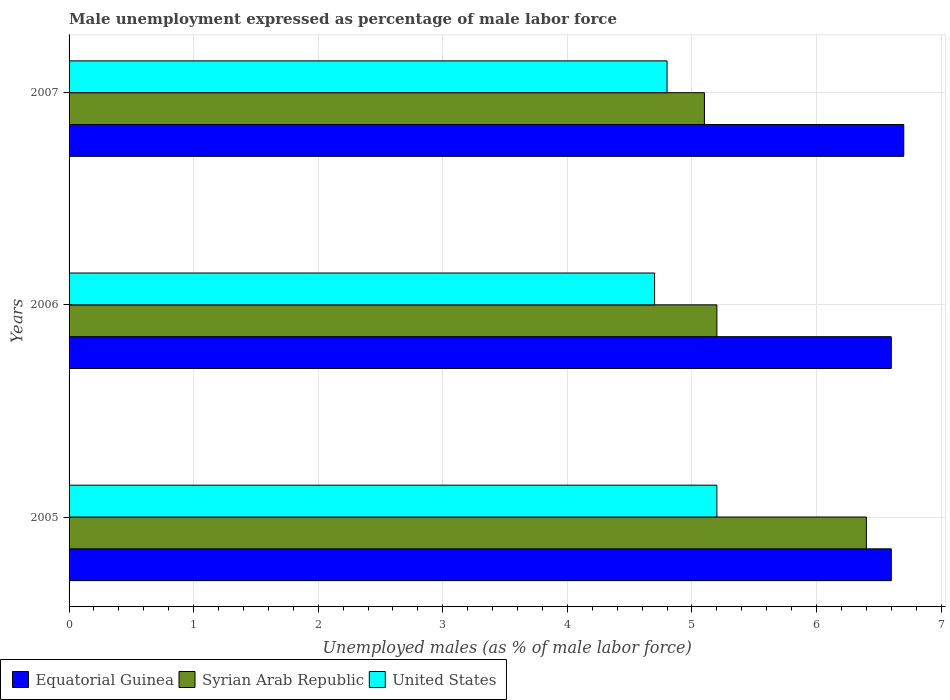How many different coloured bars are there?
Ensure brevity in your answer.  3. Are the number of bars per tick equal to the number of legend labels?
Provide a short and direct response. Yes. How many bars are there on the 2nd tick from the bottom?
Offer a very short reply. 3. In how many cases, is the number of bars for a given year not equal to the number of legend labels?
Make the answer very short. 0. What is the unemployment in males in in Equatorial Guinea in 2005?
Provide a short and direct response. 6.6. Across all years, what is the maximum unemployment in males in in Equatorial Guinea?
Make the answer very short. 6.7. Across all years, what is the minimum unemployment in males in in Equatorial Guinea?
Provide a short and direct response. 6.6. What is the total unemployment in males in in United States in the graph?
Make the answer very short. 14.7. What is the difference between the unemployment in males in in Equatorial Guinea in 2006 and that in 2007?
Make the answer very short. -0.1. What is the difference between the unemployment in males in in Equatorial Guinea in 2005 and the unemployment in males in in Syrian Arab Republic in 2007?
Offer a very short reply. 1.5. What is the average unemployment in males in in Equatorial Guinea per year?
Offer a very short reply. 6.63. In the year 2005, what is the difference between the unemployment in males in in United States and unemployment in males in in Equatorial Guinea?
Provide a short and direct response. -1.4. What is the ratio of the unemployment in males in in Equatorial Guinea in 2005 to that in 2007?
Provide a succinct answer. 0.99. What is the difference between the highest and the second highest unemployment in males in in United States?
Provide a short and direct response. 0.4. What is the difference between the highest and the lowest unemployment in males in in Equatorial Guinea?
Your response must be concise. 0.1. Is the sum of the unemployment in males in in Syrian Arab Republic in 2005 and 2007 greater than the maximum unemployment in males in in Equatorial Guinea across all years?
Provide a short and direct response. Yes. What does the 1st bar from the top in 2007 represents?
Offer a very short reply. United States. What does the 2nd bar from the bottom in 2006 represents?
Provide a succinct answer. Syrian Arab Republic. Is it the case that in every year, the sum of the unemployment in males in in Syrian Arab Republic and unemployment in males in in Equatorial Guinea is greater than the unemployment in males in in United States?
Provide a succinct answer. Yes. How many bars are there?
Offer a terse response. 9. How many years are there in the graph?
Keep it short and to the point. 3. Are the values on the major ticks of X-axis written in scientific E-notation?
Provide a short and direct response. No. Where does the legend appear in the graph?
Your answer should be very brief. Bottom left. How many legend labels are there?
Offer a terse response. 3. What is the title of the graph?
Ensure brevity in your answer.  Male unemployment expressed as percentage of male labor force. What is the label or title of the X-axis?
Keep it short and to the point. Unemployed males (as % of male labor force). What is the label or title of the Y-axis?
Ensure brevity in your answer.  Years. What is the Unemployed males (as % of male labor force) in Equatorial Guinea in 2005?
Provide a short and direct response. 6.6. What is the Unemployed males (as % of male labor force) in Syrian Arab Republic in 2005?
Give a very brief answer. 6.4. What is the Unemployed males (as % of male labor force) of United States in 2005?
Make the answer very short. 5.2. What is the Unemployed males (as % of male labor force) of Equatorial Guinea in 2006?
Give a very brief answer. 6.6. What is the Unemployed males (as % of male labor force) of Syrian Arab Republic in 2006?
Ensure brevity in your answer.  5.2. What is the Unemployed males (as % of male labor force) of United States in 2006?
Ensure brevity in your answer.  4.7. What is the Unemployed males (as % of male labor force) of Equatorial Guinea in 2007?
Provide a succinct answer. 6.7. What is the Unemployed males (as % of male labor force) of Syrian Arab Republic in 2007?
Offer a very short reply. 5.1. What is the Unemployed males (as % of male labor force) of United States in 2007?
Provide a short and direct response. 4.8. Across all years, what is the maximum Unemployed males (as % of male labor force) in Equatorial Guinea?
Offer a very short reply. 6.7. Across all years, what is the maximum Unemployed males (as % of male labor force) of Syrian Arab Republic?
Make the answer very short. 6.4. Across all years, what is the maximum Unemployed males (as % of male labor force) of United States?
Provide a succinct answer. 5.2. Across all years, what is the minimum Unemployed males (as % of male labor force) of Equatorial Guinea?
Offer a very short reply. 6.6. Across all years, what is the minimum Unemployed males (as % of male labor force) in Syrian Arab Republic?
Keep it short and to the point. 5.1. Across all years, what is the minimum Unemployed males (as % of male labor force) of United States?
Offer a very short reply. 4.7. What is the total Unemployed males (as % of male labor force) in Equatorial Guinea in the graph?
Provide a short and direct response. 19.9. What is the difference between the Unemployed males (as % of male labor force) in United States in 2005 and that in 2006?
Your response must be concise. 0.5. What is the difference between the Unemployed males (as % of male labor force) in Equatorial Guinea in 2005 and that in 2007?
Offer a very short reply. -0.1. What is the difference between the Unemployed males (as % of male labor force) of United States in 2005 and that in 2007?
Give a very brief answer. 0.4. What is the difference between the Unemployed males (as % of male labor force) in Equatorial Guinea in 2005 and the Unemployed males (as % of male labor force) in Syrian Arab Republic in 2006?
Ensure brevity in your answer.  1.4. What is the difference between the Unemployed males (as % of male labor force) in Equatorial Guinea in 2005 and the Unemployed males (as % of male labor force) in United States in 2007?
Your response must be concise. 1.8. What is the difference between the Unemployed males (as % of male labor force) of Equatorial Guinea in 2006 and the Unemployed males (as % of male labor force) of Syrian Arab Republic in 2007?
Ensure brevity in your answer.  1.5. What is the difference between the Unemployed males (as % of male labor force) of Equatorial Guinea in 2006 and the Unemployed males (as % of male labor force) of United States in 2007?
Your answer should be compact. 1.8. What is the difference between the Unemployed males (as % of male labor force) in Syrian Arab Republic in 2006 and the Unemployed males (as % of male labor force) in United States in 2007?
Give a very brief answer. 0.4. What is the average Unemployed males (as % of male labor force) of Equatorial Guinea per year?
Provide a short and direct response. 6.63. What is the average Unemployed males (as % of male labor force) of Syrian Arab Republic per year?
Your answer should be compact. 5.57. In the year 2005, what is the difference between the Unemployed males (as % of male labor force) of Equatorial Guinea and Unemployed males (as % of male labor force) of United States?
Ensure brevity in your answer.  1.4. In the year 2005, what is the difference between the Unemployed males (as % of male labor force) in Syrian Arab Republic and Unemployed males (as % of male labor force) in United States?
Give a very brief answer. 1.2. In the year 2006, what is the difference between the Unemployed males (as % of male labor force) in Equatorial Guinea and Unemployed males (as % of male labor force) in United States?
Keep it short and to the point. 1.9. In the year 2006, what is the difference between the Unemployed males (as % of male labor force) of Syrian Arab Republic and Unemployed males (as % of male labor force) of United States?
Give a very brief answer. 0.5. In the year 2007, what is the difference between the Unemployed males (as % of male labor force) in Equatorial Guinea and Unemployed males (as % of male labor force) in Syrian Arab Republic?
Your response must be concise. 1.6. In the year 2007, what is the difference between the Unemployed males (as % of male labor force) of Equatorial Guinea and Unemployed males (as % of male labor force) of United States?
Your response must be concise. 1.9. What is the ratio of the Unemployed males (as % of male labor force) of Equatorial Guinea in 2005 to that in 2006?
Make the answer very short. 1. What is the ratio of the Unemployed males (as % of male labor force) in Syrian Arab Republic in 2005 to that in 2006?
Provide a short and direct response. 1.23. What is the ratio of the Unemployed males (as % of male labor force) in United States in 2005 to that in 2006?
Make the answer very short. 1.11. What is the ratio of the Unemployed males (as % of male labor force) in Equatorial Guinea in 2005 to that in 2007?
Your answer should be compact. 0.99. What is the ratio of the Unemployed males (as % of male labor force) in Syrian Arab Republic in 2005 to that in 2007?
Your response must be concise. 1.25. What is the ratio of the Unemployed males (as % of male labor force) of Equatorial Guinea in 2006 to that in 2007?
Keep it short and to the point. 0.99. What is the ratio of the Unemployed males (as % of male labor force) in Syrian Arab Republic in 2006 to that in 2007?
Your answer should be compact. 1.02. What is the ratio of the Unemployed males (as % of male labor force) in United States in 2006 to that in 2007?
Make the answer very short. 0.98. What is the difference between the highest and the second highest Unemployed males (as % of male labor force) of United States?
Your answer should be compact. 0.4. What is the difference between the highest and the lowest Unemployed males (as % of male labor force) of Equatorial Guinea?
Your answer should be compact. 0.1. 